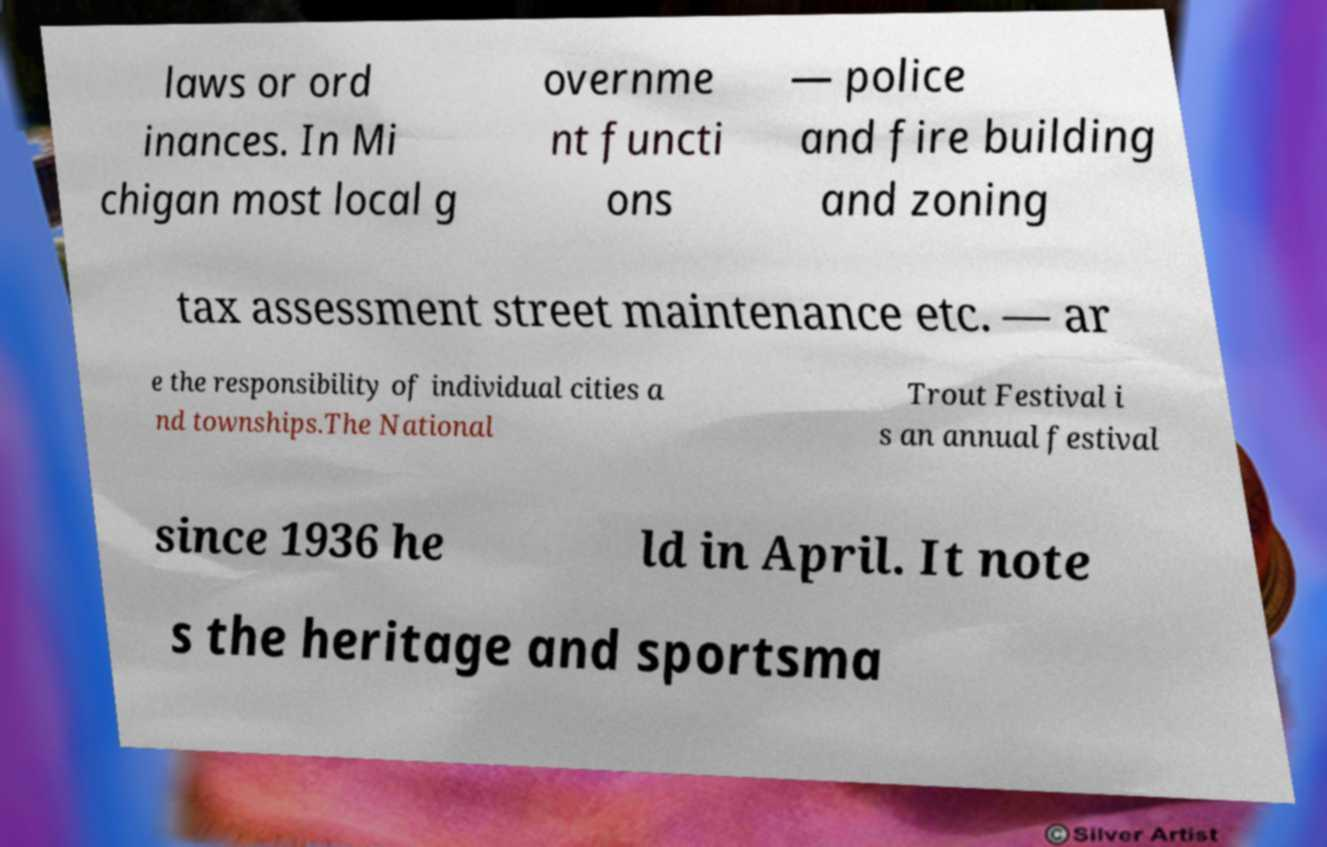For documentation purposes, I need the text within this image transcribed. Could you provide that? laws or ord inances. In Mi chigan most local g overnme nt functi ons — police and fire building and zoning tax assessment street maintenance etc. — ar e the responsibility of individual cities a nd townships.The National Trout Festival i s an annual festival since 1936 he ld in April. It note s the heritage and sportsma 